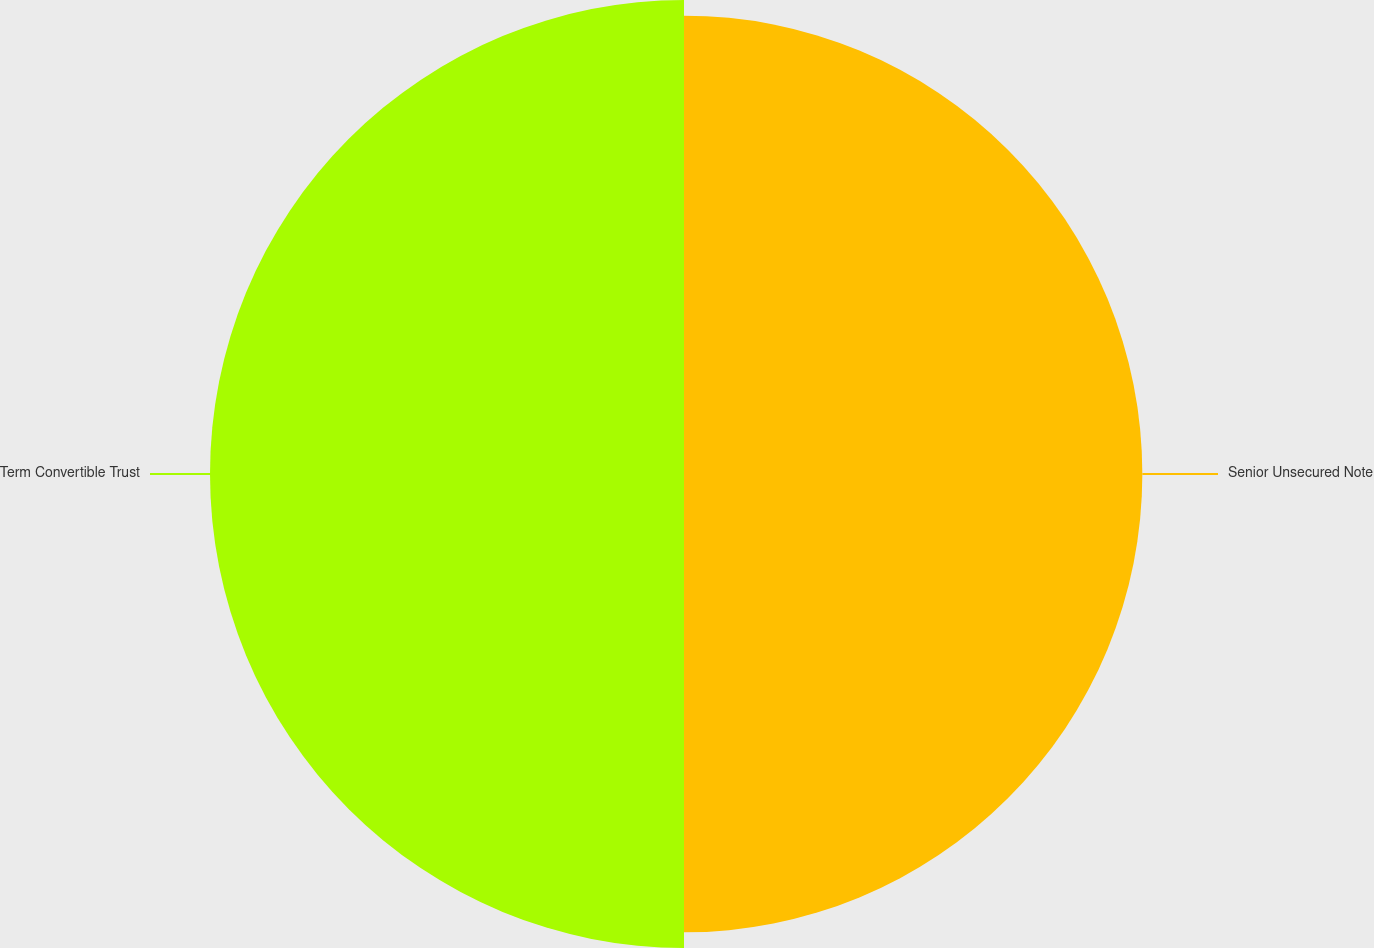Convert chart. <chart><loc_0><loc_0><loc_500><loc_500><pie_chart><fcel>Senior Unsecured Note<fcel>Term Convertible Trust<nl><fcel>49.16%<fcel>50.84%<nl></chart> 